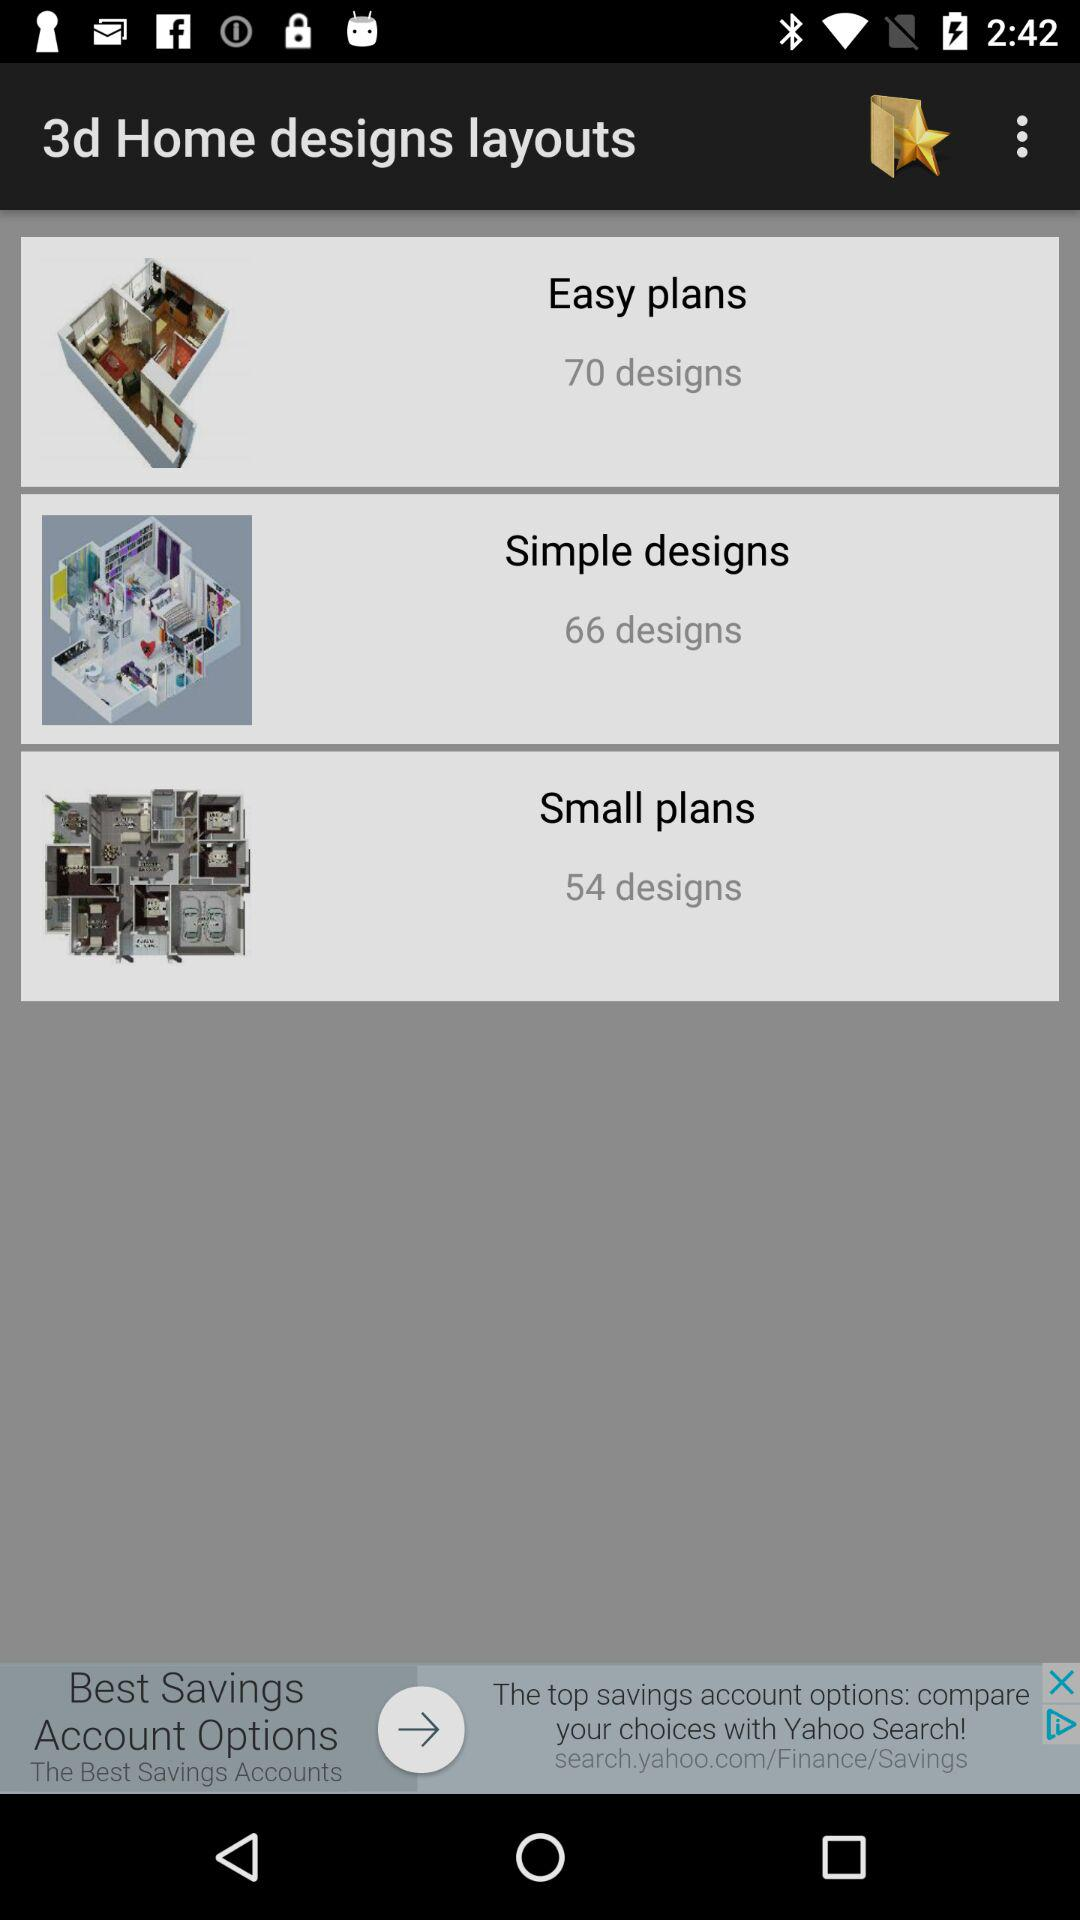What is the number of designs in "Small plans"? The number of designs in "Small plans" is 54. 